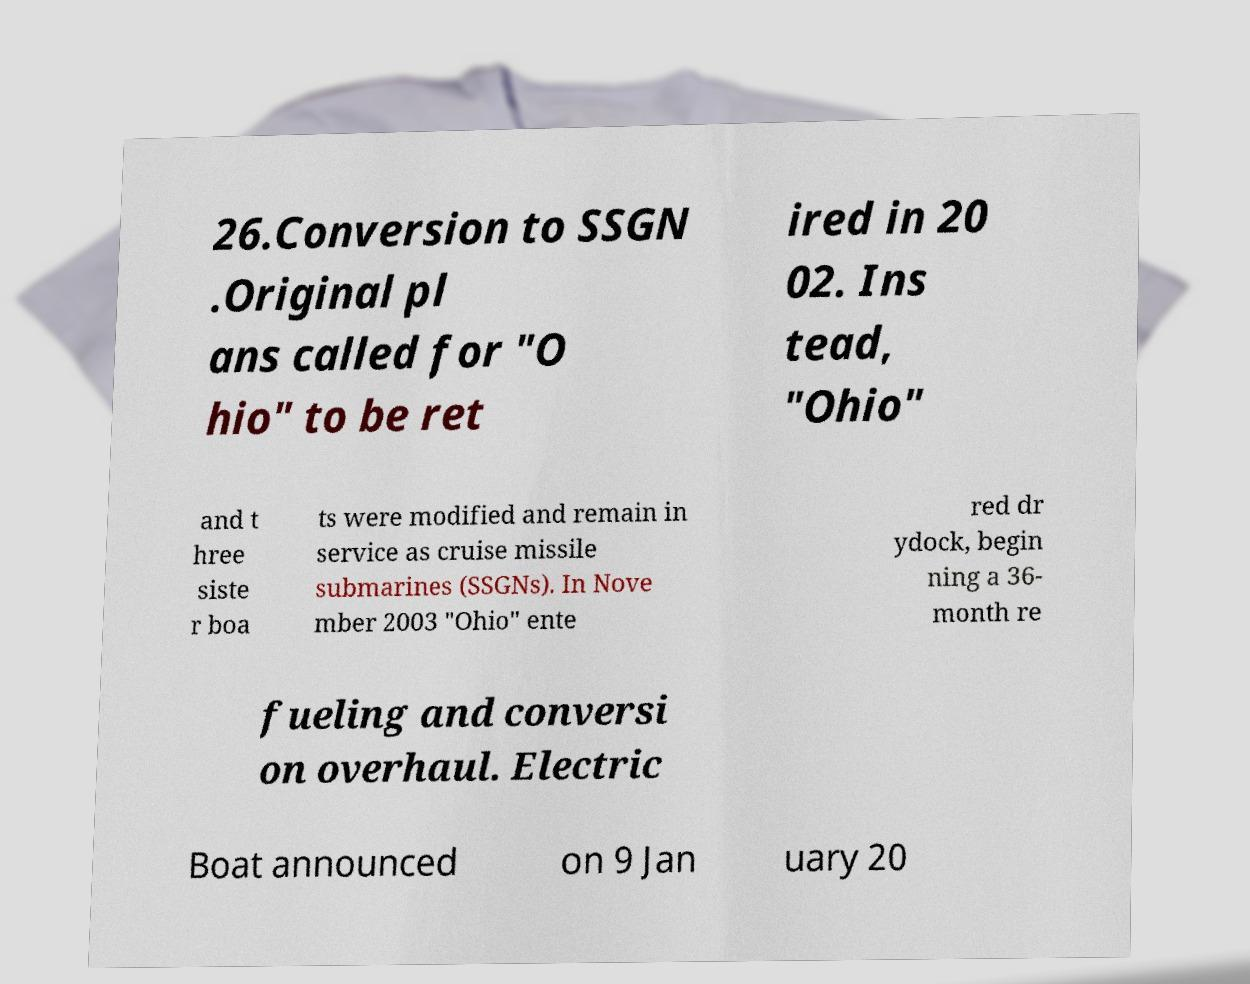Please identify and transcribe the text found in this image. 26.Conversion to SSGN .Original pl ans called for "O hio" to be ret ired in 20 02. Ins tead, "Ohio" and t hree siste r boa ts were modified and remain in service as cruise missile submarines (SSGNs). In Nove mber 2003 "Ohio" ente red dr ydock, begin ning a 36- month re fueling and conversi on overhaul. Electric Boat announced on 9 Jan uary 20 